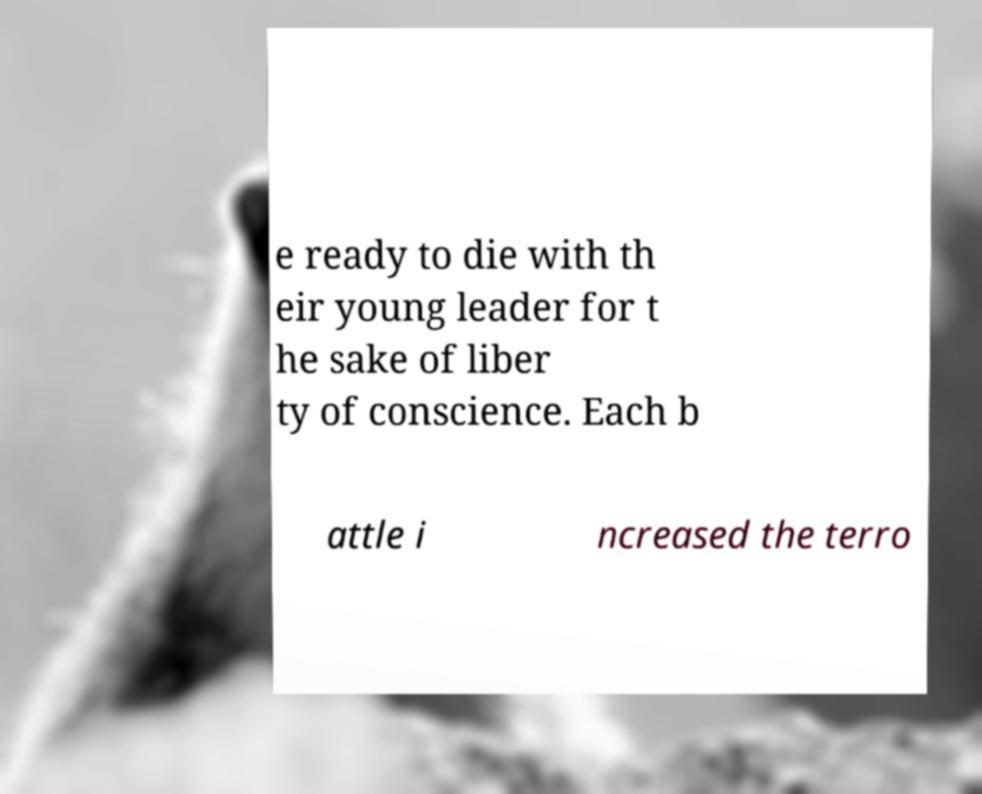Please identify and transcribe the text found in this image. e ready to die with th eir young leader for t he sake of liber ty of conscience. Each b attle i ncreased the terro 